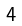<formula> <loc_0><loc_0><loc_500><loc_500>\begin{smallmatrix} 4 \end{smallmatrix}</formula> 